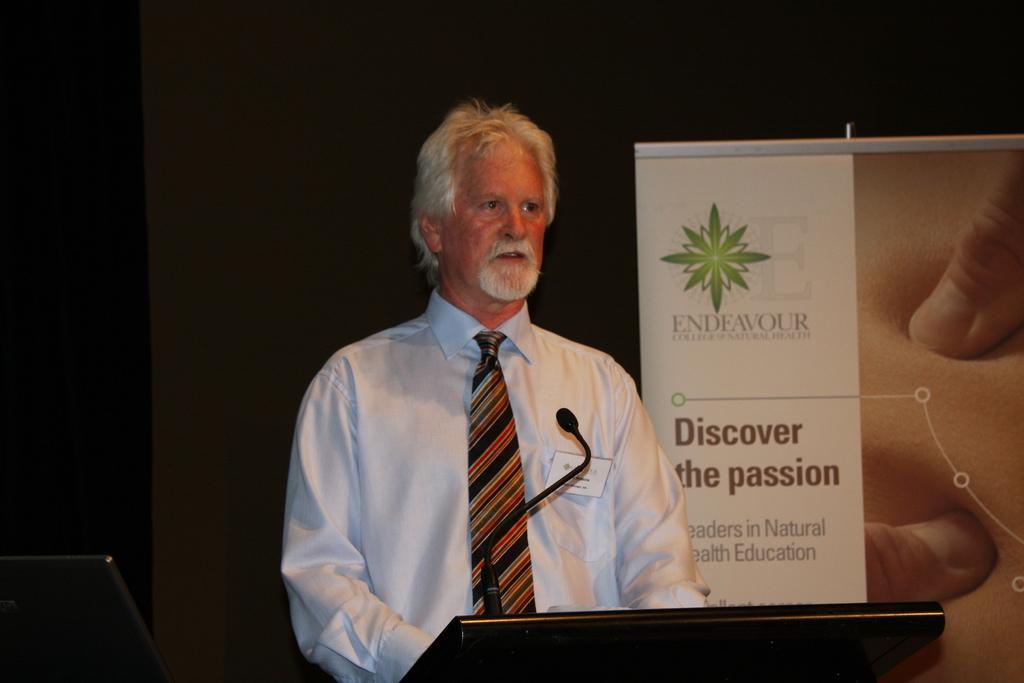Describe this image in one or two sentences. Here I can see a man standing in front of the podium and looking at the right side. On the podium there is a microphone. On the right side there is a banner on which I can see some text. In the bottom left-hand corner there is a monitor. The background is dark. 